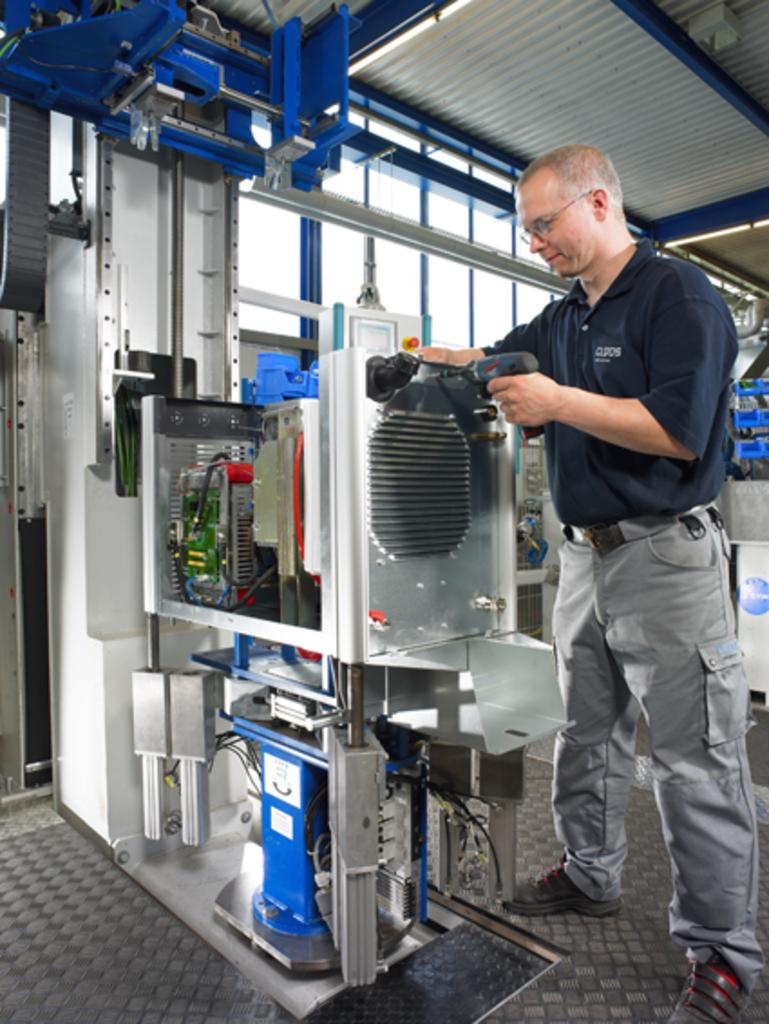Who is present in the image? There is a man in the image. What is the man wearing? The man is wearing spectacles. What is the man's position in the image? The man is standing on the floor. What is the man's facial expression? The man is smiling. What is the man holding in his hand? The man is holding a machine in his hand. What can be seen in the background of the image? There are windows in the background of the image. What type of sheet is the man using to test the machine in the image? There is no sheet present in the image, nor is the man testing the machine. 